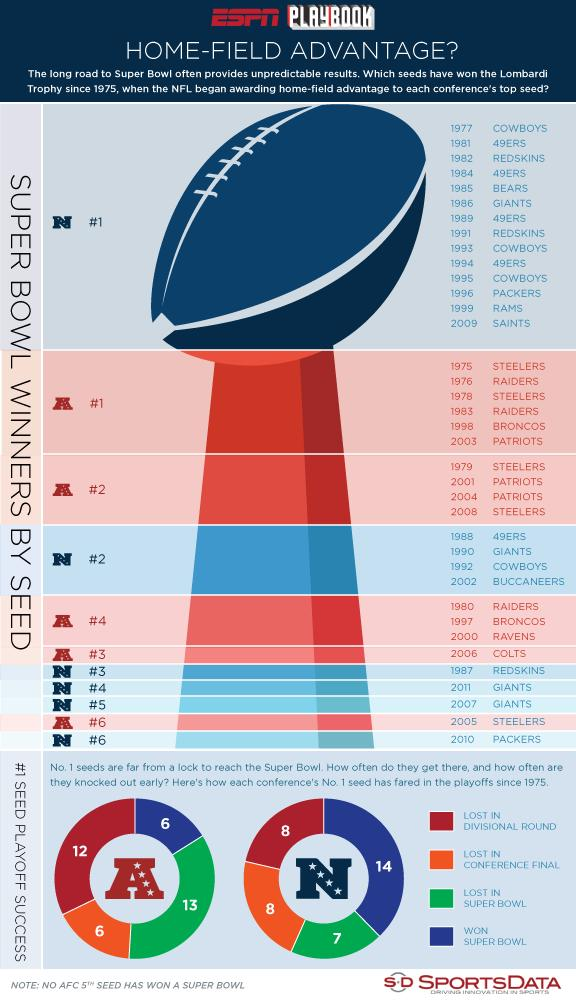Identify some key points in this picture. In 2002, the Tampa Bay Buccaneers were ranked as the number 2 team in the National Football Conference. The ranking of the Steelers in the American Football Conference in 2008 was second. The number one seed of the National Football Conference in the playoffs won 14 games. The number one seeds of the American Football Conference playoffs lost a total of 13 games. 